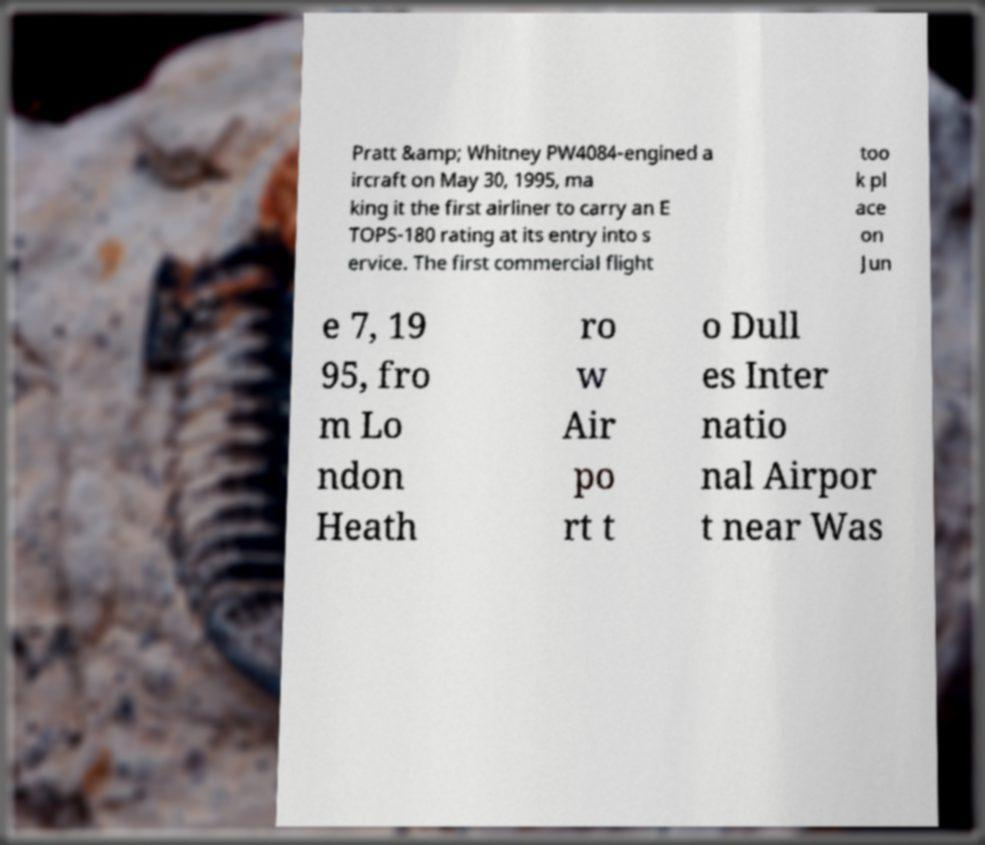Please read and relay the text visible in this image. What does it say? Pratt &amp; Whitney PW4084-engined a ircraft on May 30, 1995, ma king it the first airliner to carry an E TOPS-180 rating at its entry into s ervice. The first commercial flight too k pl ace on Jun e 7, 19 95, fro m Lo ndon Heath ro w Air po rt t o Dull es Inter natio nal Airpor t near Was 